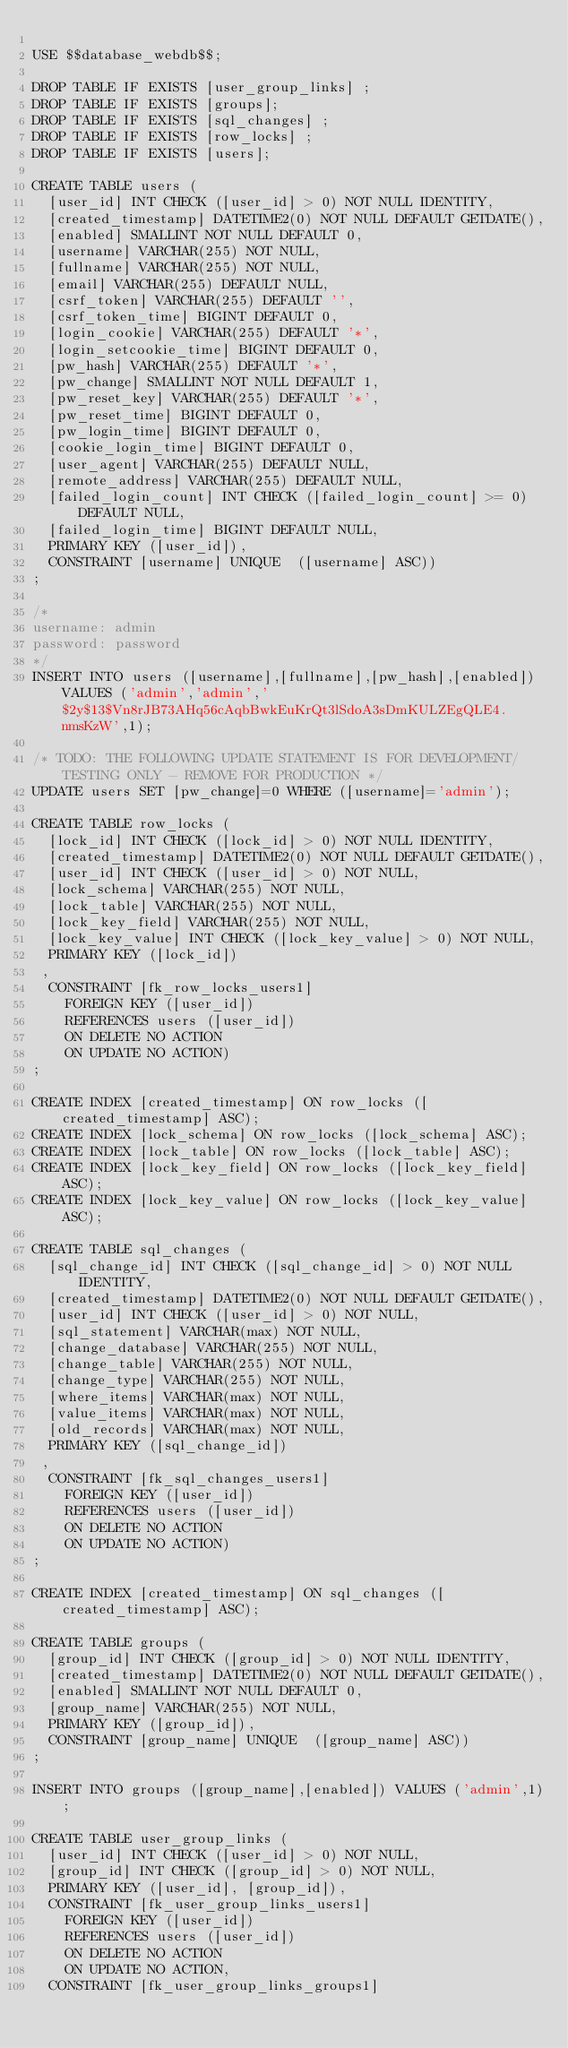Convert code to text. <code><loc_0><loc_0><loc_500><loc_500><_SQL_>
USE $$database_webdb$$;

DROP TABLE IF EXISTS [user_group_links] ;
DROP TABLE IF EXISTS [groups];
DROP TABLE IF EXISTS [sql_changes] ;
DROP TABLE IF EXISTS [row_locks] ;
DROP TABLE IF EXISTS [users];

CREATE TABLE users (
  [user_id] INT CHECK ([user_id] > 0) NOT NULL IDENTITY,
  [created_timestamp] DATETIME2(0) NOT NULL DEFAULT GETDATE(),
  [enabled] SMALLINT NOT NULL DEFAULT 0,
  [username] VARCHAR(255) NOT NULL,
  [fullname] VARCHAR(255) NOT NULL,
  [email] VARCHAR(255) DEFAULT NULL,
  [csrf_token] VARCHAR(255) DEFAULT '',
  [csrf_token_time] BIGINT DEFAULT 0,
  [login_cookie] VARCHAR(255) DEFAULT '*',
  [login_setcookie_time] BIGINT DEFAULT 0,
  [pw_hash] VARCHAR(255) DEFAULT '*',
  [pw_change] SMALLINT NOT NULL DEFAULT 1,
  [pw_reset_key] VARCHAR(255) DEFAULT '*',
  [pw_reset_time] BIGINT DEFAULT 0,
  [pw_login_time] BIGINT DEFAULT 0,
  [cookie_login_time] BIGINT DEFAULT 0,
  [user_agent] VARCHAR(255) DEFAULT NULL,
  [remote_address] VARCHAR(255) DEFAULT NULL,
  [failed_login_count] INT CHECK ([failed_login_count] >= 0) DEFAULT NULL,
  [failed_login_time] BIGINT DEFAULT NULL,
  PRIMARY KEY ([user_id]),
  CONSTRAINT [username] UNIQUE  ([username] ASC))
;

/*
username: admin
password: password
*/
INSERT INTO users ([username],[fullname],[pw_hash],[enabled]) VALUES ('admin','admin','$2y$13$Vn8rJB73AHq56cAqbBwkEuKrQt3lSdoA3sDmKULZEgQLE4.nmsKzW',1);

/* TODO: THE FOLLOWING UPDATE STATEMENT IS FOR DEVELOPMENT/TESTING ONLY - REMOVE FOR PRODUCTION */
UPDATE users SET [pw_change]=0 WHERE ([username]='admin');

CREATE TABLE row_locks (
  [lock_id] INT CHECK ([lock_id] > 0) NOT NULL IDENTITY,
  [created_timestamp] DATETIME2(0) NOT NULL DEFAULT GETDATE(),
  [user_id] INT CHECK ([user_id] > 0) NOT NULL,
  [lock_schema] VARCHAR(255) NOT NULL,
  [lock_table] VARCHAR(255) NOT NULL,
  [lock_key_field] VARCHAR(255) NOT NULL,
  [lock_key_value] INT CHECK ([lock_key_value] > 0) NOT NULL,
  PRIMARY KEY ([lock_id])
 ,
  CONSTRAINT [fk_row_locks_users1]
    FOREIGN KEY ([user_id])
    REFERENCES users ([user_id])
    ON DELETE NO ACTION
    ON UPDATE NO ACTION)
;

CREATE INDEX [created_timestamp] ON row_locks ([created_timestamp] ASC);
CREATE INDEX [lock_schema] ON row_locks ([lock_schema] ASC);
CREATE INDEX [lock_table] ON row_locks ([lock_table] ASC);
CREATE INDEX [lock_key_field] ON row_locks ([lock_key_field] ASC);
CREATE INDEX [lock_key_value] ON row_locks ([lock_key_value] ASC);

CREATE TABLE sql_changes (
  [sql_change_id] INT CHECK ([sql_change_id] > 0) NOT NULL IDENTITY,
  [created_timestamp] DATETIME2(0) NOT NULL DEFAULT GETDATE(),
  [user_id] INT CHECK ([user_id] > 0) NOT NULL,
  [sql_statement] VARCHAR(max) NOT NULL,
  [change_database] VARCHAR(255) NOT NULL,
  [change_table] VARCHAR(255) NOT NULL,
  [change_type] VARCHAR(255) NOT NULL,
  [where_items] VARCHAR(max) NOT NULL,
  [value_items] VARCHAR(max) NOT NULL,
  [old_records] VARCHAR(max) NOT NULL,
  PRIMARY KEY ([sql_change_id])
 ,
  CONSTRAINT [fk_sql_changes_users1]
    FOREIGN KEY ([user_id])
    REFERENCES users ([user_id])
    ON DELETE NO ACTION
    ON UPDATE NO ACTION)
;

CREATE INDEX [created_timestamp] ON sql_changes ([created_timestamp] ASC);

CREATE TABLE groups (
  [group_id] INT CHECK ([group_id] > 0) NOT NULL IDENTITY,
  [created_timestamp] DATETIME2(0) NOT NULL DEFAULT GETDATE(),
  [enabled] SMALLINT NOT NULL DEFAULT 0,
  [group_name] VARCHAR(255) NOT NULL,
  PRIMARY KEY ([group_id]),
  CONSTRAINT [group_name] UNIQUE  ([group_name] ASC))
;

INSERT INTO groups ([group_name],[enabled]) VALUES ('admin',1);

CREATE TABLE user_group_links (
  [user_id] INT CHECK ([user_id] > 0) NOT NULL,
  [group_id] INT CHECK ([group_id] > 0) NOT NULL,
  PRIMARY KEY ([user_id], [group_id]),
  CONSTRAINT [fk_user_group_links_users1]
    FOREIGN KEY ([user_id])
    REFERENCES users ([user_id])
    ON DELETE NO ACTION
    ON UPDATE NO ACTION,
  CONSTRAINT [fk_user_group_links_groups1]</code> 